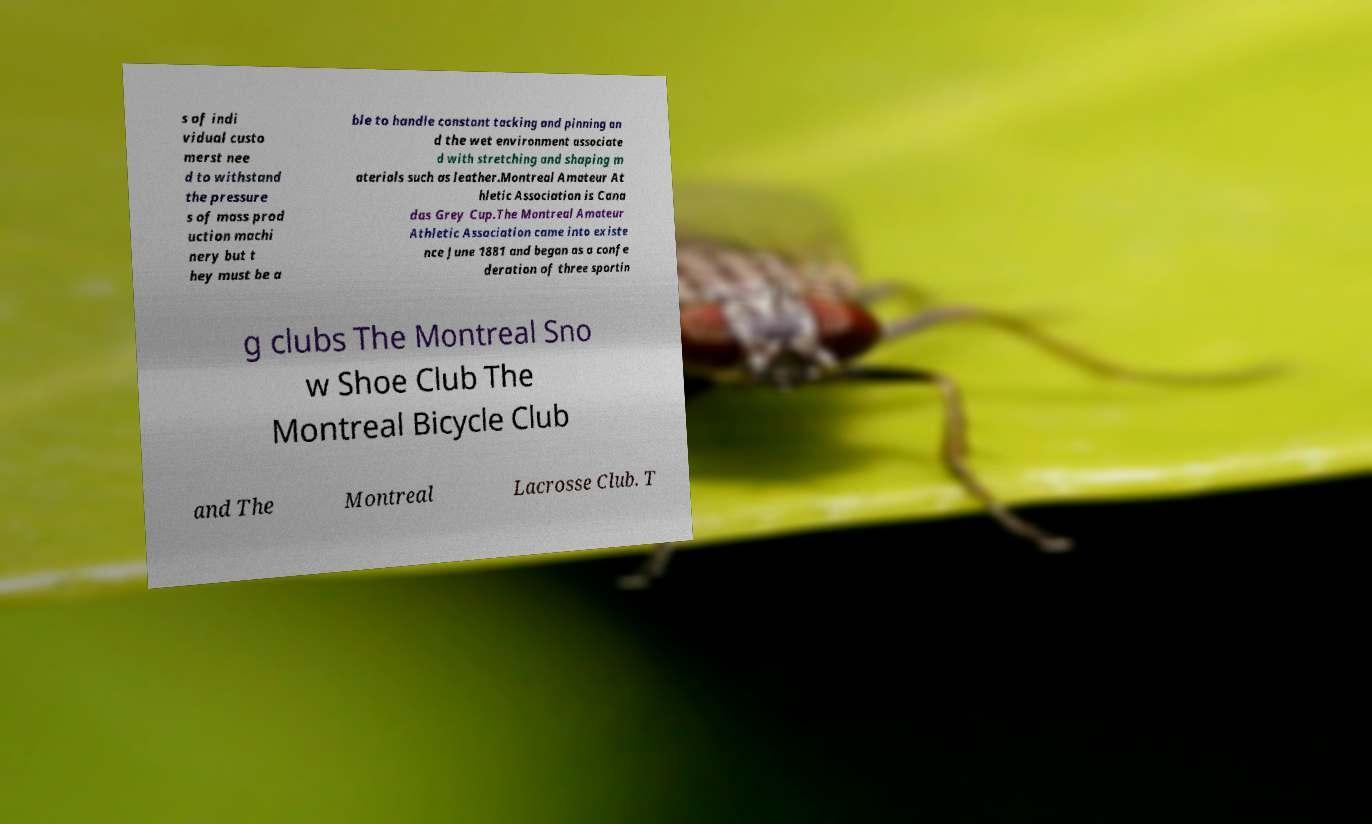What messages or text are displayed in this image? I need them in a readable, typed format. s of indi vidual custo merst nee d to withstand the pressure s of mass prod uction machi nery but t hey must be a ble to handle constant tacking and pinning an d the wet environment associate d with stretching and shaping m aterials such as leather.Montreal Amateur At hletic Association is Cana das Grey Cup.The Montreal Amateur Athletic Association came into existe nce June 1881 and began as a confe deration of three sportin g clubs The Montreal Sno w Shoe Club The Montreal Bicycle Club and The Montreal Lacrosse Club. T 